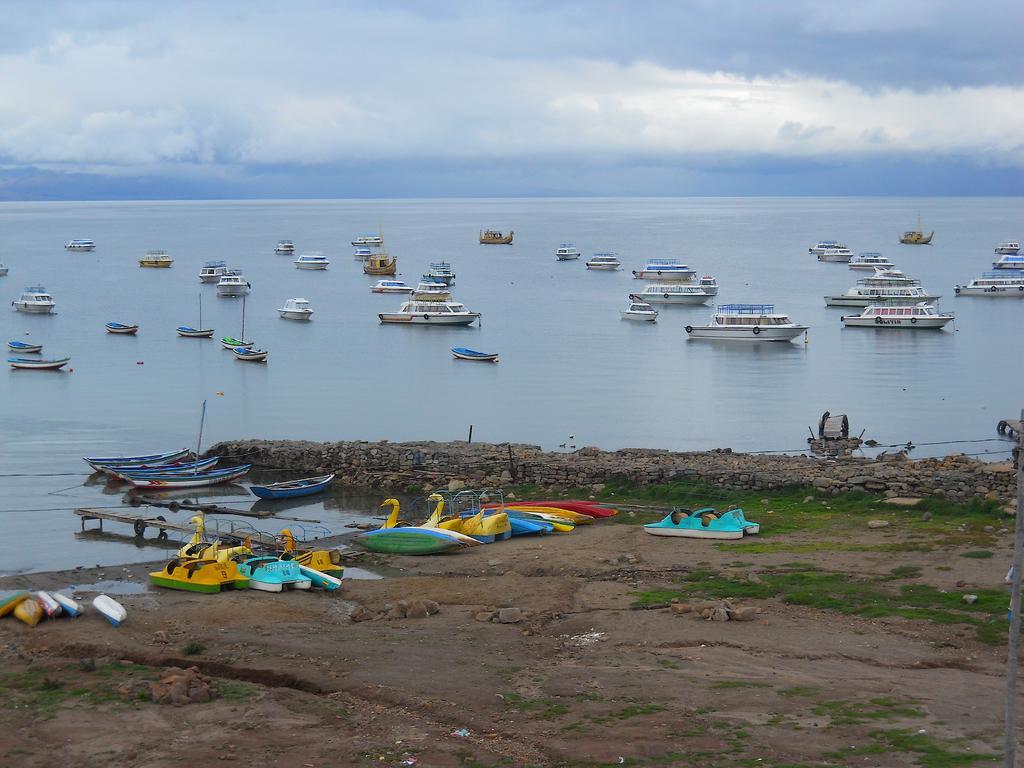How would you summarize this image in a sentence or two? In this image I can see a few boats and they are in different color. In front I can see a colorful duck boats on the ground. We can see a water,poles and bridge. The sky is in white and blue color. 